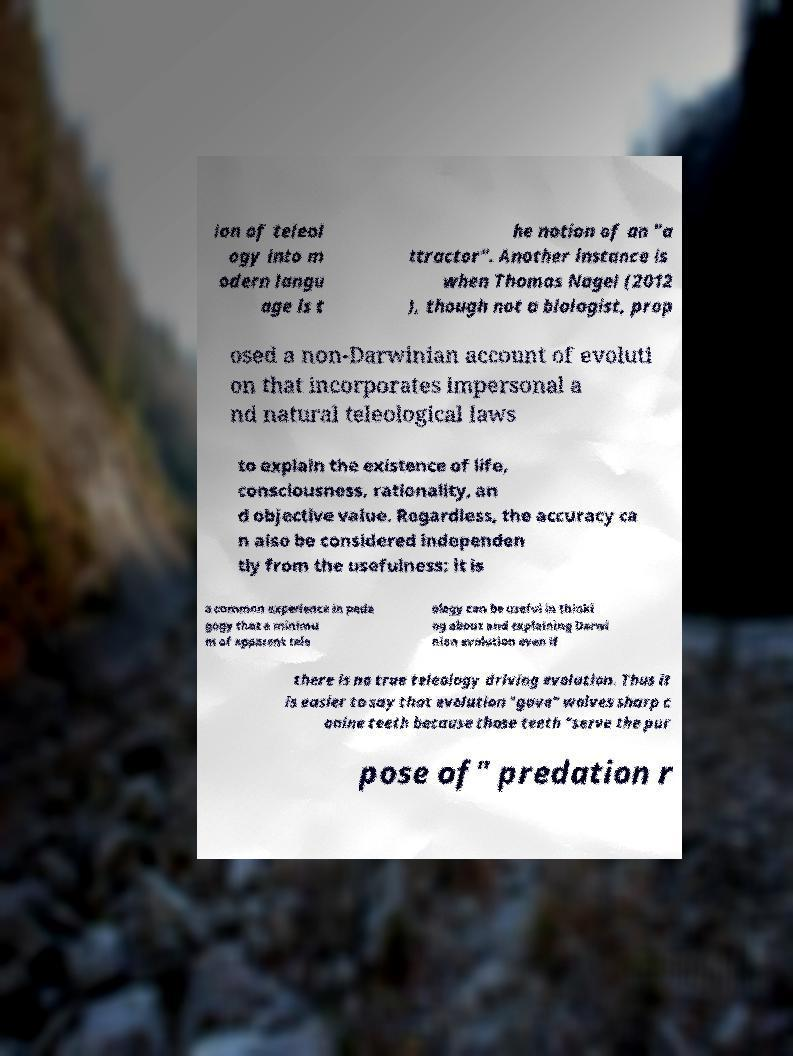What messages or text are displayed in this image? I need them in a readable, typed format. ion of teleol ogy into m odern langu age is t he notion of an "a ttractor". Another instance is when Thomas Nagel (2012 ), though not a biologist, prop osed a non-Darwinian account of evoluti on that incorporates impersonal a nd natural teleological laws to explain the existence of life, consciousness, rationality, an d objective value. Regardless, the accuracy ca n also be considered independen tly from the usefulness: it is a common experience in peda gogy that a minimu m of apparent tele ology can be useful in thinki ng about and explaining Darwi nian evolution even if there is no true teleology driving evolution. Thus it is easier to say that evolution "gave" wolves sharp c anine teeth because those teeth "serve the pur pose of" predation r 